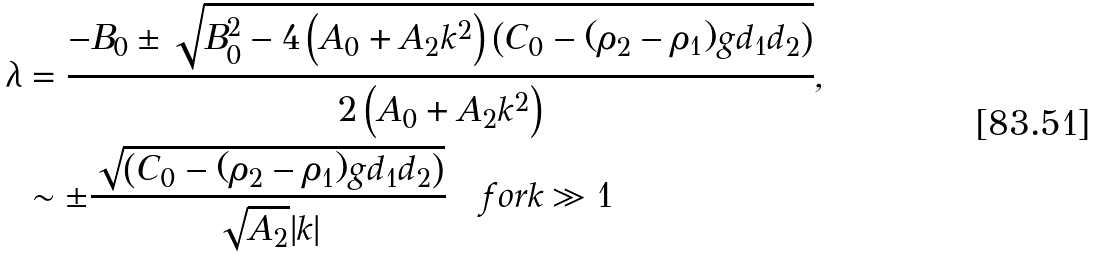Convert formula to latex. <formula><loc_0><loc_0><loc_500><loc_500>\lambda & = \frac { - B _ { 0 } \pm \sqrt { B _ { 0 } ^ { 2 } - 4 \left ( A _ { 0 } + A _ { 2 } k ^ { 2 } \right ) \left ( C _ { 0 } - ( \rho _ { 2 } - \rho _ { 1 } ) g d _ { 1 } d _ { 2 } \right ) } } { 2 \left ( A _ { 0 } + A _ { 2 } k ^ { 2 } \right ) } , \\ & \sim \pm \frac { \sqrt { \left ( C _ { 0 } - ( \rho _ { 2 } - \rho _ { 1 } ) g d _ { 1 } d _ { 2 } \right ) } } { \sqrt { A _ { 2 } } | k | } \quad f o r k \gg 1</formula> 